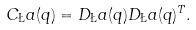Convert formula to latex. <formula><loc_0><loc_0><loc_500><loc_500>C _ { \L } a ( q ) = D _ { \L } a ( q ) D _ { \L } a ( q ) ^ { T } .</formula> 